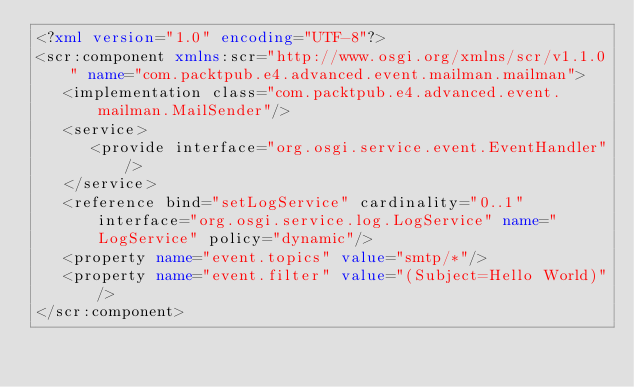<code> <loc_0><loc_0><loc_500><loc_500><_XML_><?xml version="1.0" encoding="UTF-8"?>
<scr:component xmlns:scr="http://www.osgi.org/xmlns/scr/v1.1.0" name="com.packtpub.e4.advanced.event.mailman.mailman">
   <implementation class="com.packtpub.e4.advanced.event.mailman.MailSender"/>
   <service>
      <provide interface="org.osgi.service.event.EventHandler"/>
   </service>
   <reference bind="setLogService" cardinality="0..1" interface="org.osgi.service.log.LogService" name="LogService" policy="dynamic"/>
   <property name="event.topics" value="smtp/*"/>
   <property name="event.filter" value="(Subject=Hello World)"/>
</scr:component>
</code> 